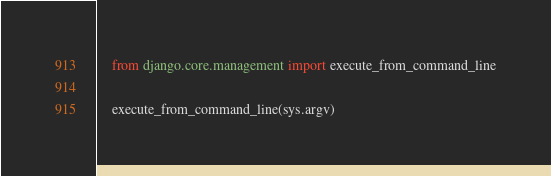<code> <loc_0><loc_0><loc_500><loc_500><_Python_>    from django.core.management import execute_from_command_line

    execute_from_command_line(sys.argv)
</code> 